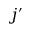<formula> <loc_0><loc_0><loc_500><loc_500>j ^ { \prime }</formula> 